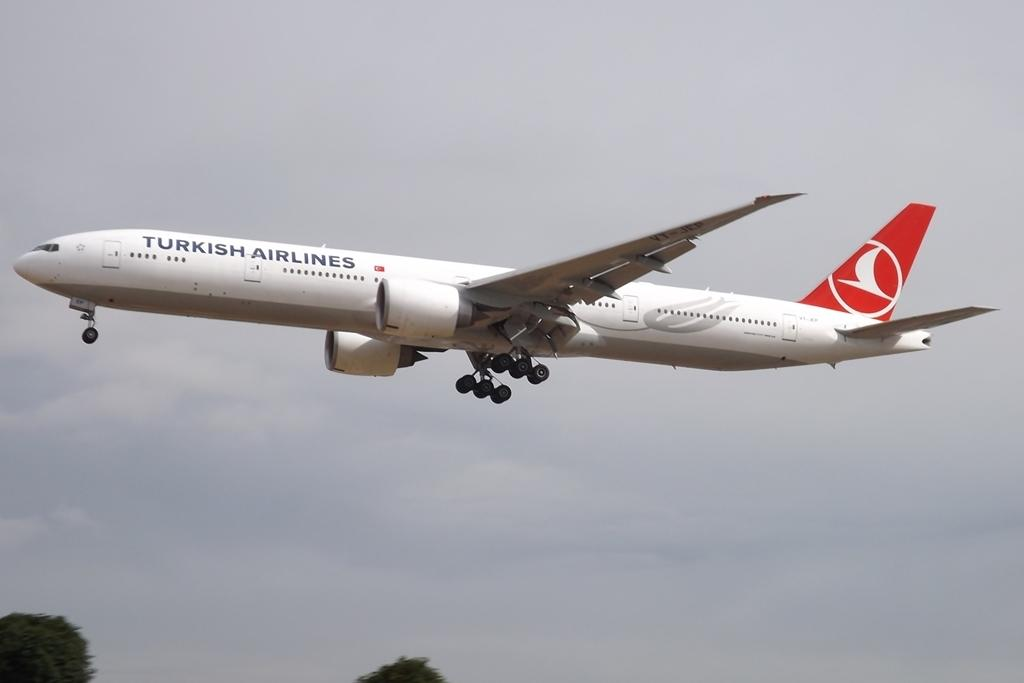<image>
Offer a succinct explanation of the picture presented. A Turkish Airlines airplane is flying in cloudy skies. 